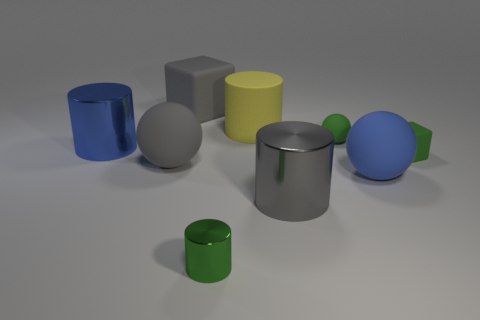Is the number of tiny matte blocks left of the big blue metallic cylinder less than the number of gray balls right of the gray metal cylinder?
Provide a short and direct response. No. There is a large yellow matte cylinder; what number of large matte cubes are in front of it?
Your answer should be very brief. 0. There is a big shiny thing that is right of the yellow matte cylinder; does it have the same shape as the large yellow object that is behind the tiny metallic object?
Ensure brevity in your answer.  Yes. How many other things are there of the same color as the small block?
Provide a short and direct response. 2. There is a green cube on the right side of the large ball to the right of the big matte sphere left of the green cylinder; what is it made of?
Offer a terse response. Rubber. The big blue thing behind the blue matte thing on the right side of the tiny metal cylinder is made of what material?
Your answer should be compact. Metal. Are there fewer small green matte cubes in front of the large yellow matte cylinder than blue matte balls?
Offer a terse response. No. The blue object right of the large blue metal cylinder has what shape?
Offer a very short reply. Sphere. Does the blue rubber object have the same size as the gray block right of the blue metallic cylinder?
Offer a very short reply. Yes. Is there a block made of the same material as the blue sphere?
Ensure brevity in your answer.  Yes. 